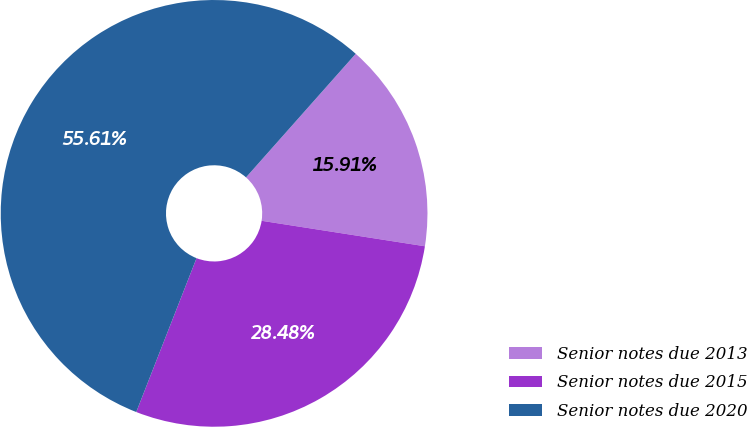Convert chart to OTSL. <chart><loc_0><loc_0><loc_500><loc_500><pie_chart><fcel>Senior notes due 2013<fcel>Senior notes due 2015<fcel>Senior notes due 2020<nl><fcel>15.91%<fcel>28.48%<fcel>55.61%<nl></chart> 